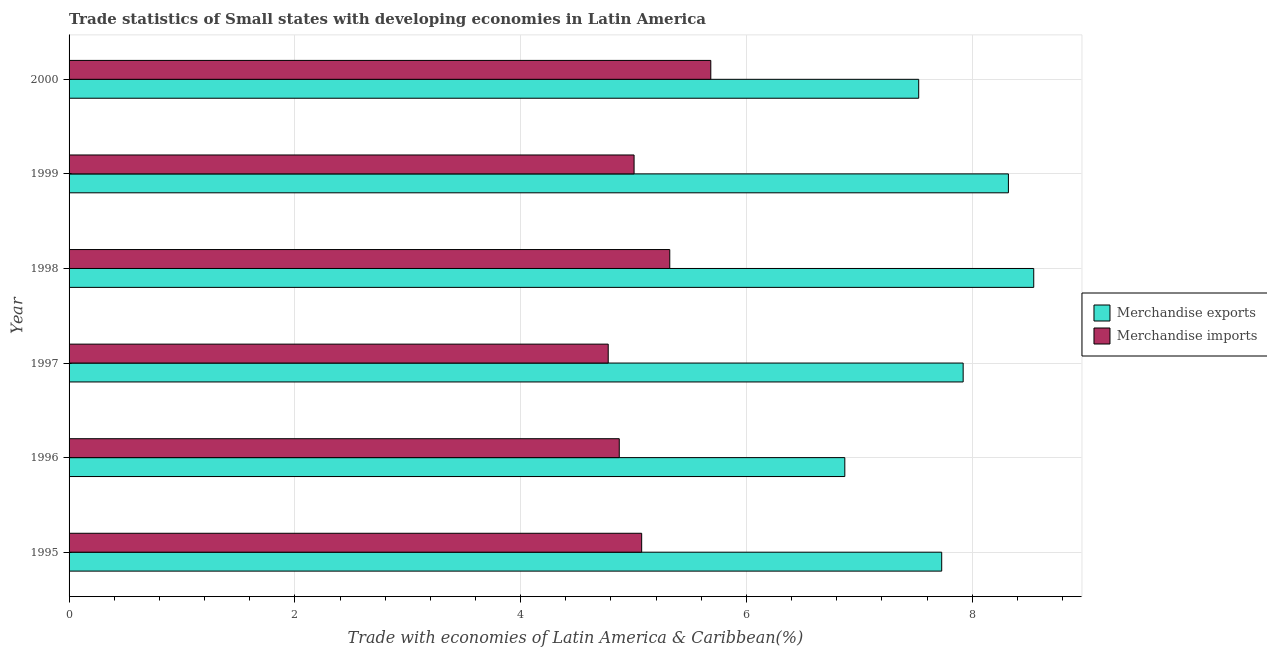How many groups of bars are there?
Give a very brief answer. 6. Are the number of bars on each tick of the Y-axis equal?
Provide a succinct answer. Yes. How many bars are there on the 5th tick from the bottom?
Offer a very short reply. 2. What is the label of the 6th group of bars from the top?
Your answer should be compact. 1995. What is the merchandise exports in 1997?
Keep it short and to the point. 7.92. Across all years, what is the maximum merchandise exports?
Provide a short and direct response. 8.54. Across all years, what is the minimum merchandise imports?
Give a very brief answer. 4.78. In which year was the merchandise imports minimum?
Your answer should be very brief. 1997. What is the total merchandise exports in the graph?
Offer a terse response. 46.91. What is the difference between the merchandise imports in 1995 and that in 2000?
Your answer should be very brief. -0.61. What is the difference between the merchandise imports in 1998 and the merchandise exports in 2000?
Keep it short and to the point. -2.21. What is the average merchandise exports per year?
Keep it short and to the point. 7.82. In the year 1995, what is the difference between the merchandise imports and merchandise exports?
Your response must be concise. -2.66. In how many years, is the merchandise exports greater than 4.4 %?
Provide a short and direct response. 6. What is the ratio of the merchandise imports in 1998 to that in 1999?
Offer a terse response. 1.06. What is the difference between the highest and the second highest merchandise exports?
Offer a very short reply. 0.22. What is the difference between the highest and the lowest merchandise exports?
Make the answer very short. 1.67. Is the sum of the merchandise imports in 1998 and 1999 greater than the maximum merchandise exports across all years?
Offer a terse response. Yes. What does the 1st bar from the top in 1997 represents?
Keep it short and to the point. Merchandise imports. Are all the bars in the graph horizontal?
Your response must be concise. Yes. How many years are there in the graph?
Ensure brevity in your answer.  6. Does the graph contain grids?
Give a very brief answer. Yes. Where does the legend appear in the graph?
Ensure brevity in your answer.  Center right. What is the title of the graph?
Keep it short and to the point. Trade statistics of Small states with developing economies in Latin America. Does "Nitrous oxide emissions" appear as one of the legend labels in the graph?
Make the answer very short. No. What is the label or title of the X-axis?
Keep it short and to the point. Trade with economies of Latin America & Caribbean(%). What is the Trade with economies of Latin America & Caribbean(%) of Merchandise exports in 1995?
Provide a short and direct response. 7.73. What is the Trade with economies of Latin America & Caribbean(%) of Merchandise imports in 1995?
Make the answer very short. 5.07. What is the Trade with economies of Latin America & Caribbean(%) of Merchandise exports in 1996?
Offer a terse response. 6.87. What is the Trade with economies of Latin America & Caribbean(%) in Merchandise imports in 1996?
Provide a succinct answer. 4.87. What is the Trade with economies of Latin America & Caribbean(%) in Merchandise exports in 1997?
Make the answer very short. 7.92. What is the Trade with economies of Latin America & Caribbean(%) of Merchandise imports in 1997?
Your answer should be very brief. 4.78. What is the Trade with economies of Latin America & Caribbean(%) of Merchandise exports in 1998?
Provide a succinct answer. 8.54. What is the Trade with economies of Latin America & Caribbean(%) in Merchandise imports in 1998?
Ensure brevity in your answer.  5.32. What is the Trade with economies of Latin America & Caribbean(%) in Merchandise exports in 1999?
Your answer should be very brief. 8.32. What is the Trade with economies of Latin America & Caribbean(%) of Merchandise imports in 1999?
Provide a short and direct response. 5. What is the Trade with economies of Latin America & Caribbean(%) in Merchandise exports in 2000?
Ensure brevity in your answer.  7.53. What is the Trade with economies of Latin America & Caribbean(%) of Merchandise imports in 2000?
Your response must be concise. 5.68. Across all years, what is the maximum Trade with economies of Latin America & Caribbean(%) in Merchandise exports?
Your answer should be very brief. 8.54. Across all years, what is the maximum Trade with economies of Latin America & Caribbean(%) of Merchandise imports?
Make the answer very short. 5.68. Across all years, what is the minimum Trade with economies of Latin America & Caribbean(%) in Merchandise exports?
Offer a very short reply. 6.87. Across all years, what is the minimum Trade with economies of Latin America & Caribbean(%) of Merchandise imports?
Make the answer very short. 4.78. What is the total Trade with economies of Latin America & Caribbean(%) in Merchandise exports in the graph?
Offer a terse response. 46.91. What is the total Trade with economies of Latin America & Caribbean(%) in Merchandise imports in the graph?
Offer a very short reply. 30.73. What is the difference between the Trade with economies of Latin America & Caribbean(%) in Merchandise exports in 1995 and that in 1996?
Offer a very short reply. 0.86. What is the difference between the Trade with economies of Latin America & Caribbean(%) of Merchandise imports in 1995 and that in 1996?
Make the answer very short. 0.2. What is the difference between the Trade with economies of Latin America & Caribbean(%) in Merchandise exports in 1995 and that in 1997?
Offer a very short reply. -0.19. What is the difference between the Trade with economies of Latin America & Caribbean(%) in Merchandise imports in 1995 and that in 1997?
Make the answer very short. 0.3. What is the difference between the Trade with economies of Latin America & Caribbean(%) of Merchandise exports in 1995 and that in 1998?
Offer a terse response. -0.82. What is the difference between the Trade with economies of Latin America & Caribbean(%) in Merchandise imports in 1995 and that in 1998?
Offer a terse response. -0.25. What is the difference between the Trade with economies of Latin America & Caribbean(%) of Merchandise exports in 1995 and that in 1999?
Your response must be concise. -0.59. What is the difference between the Trade with economies of Latin America & Caribbean(%) of Merchandise imports in 1995 and that in 1999?
Ensure brevity in your answer.  0.07. What is the difference between the Trade with economies of Latin America & Caribbean(%) in Merchandise exports in 1995 and that in 2000?
Keep it short and to the point. 0.2. What is the difference between the Trade with economies of Latin America & Caribbean(%) of Merchandise imports in 1995 and that in 2000?
Ensure brevity in your answer.  -0.61. What is the difference between the Trade with economies of Latin America & Caribbean(%) in Merchandise exports in 1996 and that in 1997?
Offer a very short reply. -1.05. What is the difference between the Trade with economies of Latin America & Caribbean(%) of Merchandise imports in 1996 and that in 1997?
Make the answer very short. 0.1. What is the difference between the Trade with economies of Latin America & Caribbean(%) of Merchandise exports in 1996 and that in 1998?
Your answer should be very brief. -1.67. What is the difference between the Trade with economies of Latin America & Caribbean(%) in Merchandise imports in 1996 and that in 1998?
Ensure brevity in your answer.  -0.45. What is the difference between the Trade with economies of Latin America & Caribbean(%) of Merchandise exports in 1996 and that in 1999?
Keep it short and to the point. -1.45. What is the difference between the Trade with economies of Latin America & Caribbean(%) in Merchandise imports in 1996 and that in 1999?
Offer a terse response. -0.13. What is the difference between the Trade with economies of Latin America & Caribbean(%) in Merchandise exports in 1996 and that in 2000?
Keep it short and to the point. -0.65. What is the difference between the Trade with economies of Latin America & Caribbean(%) in Merchandise imports in 1996 and that in 2000?
Offer a terse response. -0.81. What is the difference between the Trade with economies of Latin America & Caribbean(%) of Merchandise exports in 1997 and that in 1998?
Offer a terse response. -0.63. What is the difference between the Trade with economies of Latin America & Caribbean(%) in Merchandise imports in 1997 and that in 1998?
Your answer should be very brief. -0.55. What is the difference between the Trade with economies of Latin America & Caribbean(%) in Merchandise exports in 1997 and that in 1999?
Your answer should be very brief. -0.4. What is the difference between the Trade with economies of Latin America & Caribbean(%) of Merchandise imports in 1997 and that in 1999?
Provide a short and direct response. -0.23. What is the difference between the Trade with economies of Latin America & Caribbean(%) in Merchandise exports in 1997 and that in 2000?
Make the answer very short. 0.39. What is the difference between the Trade with economies of Latin America & Caribbean(%) in Merchandise imports in 1997 and that in 2000?
Offer a very short reply. -0.91. What is the difference between the Trade with economies of Latin America & Caribbean(%) of Merchandise exports in 1998 and that in 1999?
Your answer should be very brief. 0.22. What is the difference between the Trade with economies of Latin America & Caribbean(%) in Merchandise imports in 1998 and that in 1999?
Your response must be concise. 0.32. What is the difference between the Trade with economies of Latin America & Caribbean(%) of Merchandise exports in 1998 and that in 2000?
Your response must be concise. 1.02. What is the difference between the Trade with economies of Latin America & Caribbean(%) of Merchandise imports in 1998 and that in 2000?
Provide a short and direct response. -0.36. What is the difference between the Trade with economies of Latin America & Caribbean(%) of Merchandise exports in 1999 and that in 2000?
Your answer should be very brief. 0.79. What is the difference between the Trade with economies of Latin America & Caribbean(%) of Merchandise imports in 1999 and that in 2000?
Make the answer very short. -0.68. What is the difference between the Trade with economies of Latin America & Caribbean(%) of Merchandise exports in 1995 and the Trade with economies of Latin America & Caribbean(%) of Merchandise imports in 1996?
Give a very brief answer. 2.86. What is the difference between the Trade with economies of Latin America & Caribbean(%) in Merchandise exports in 1995 and the Trade with economies of Latin America & Caribbean(%) in Merchandise imports in 1997?
Provide a short and direct response. 2.95. What is the difference between the Trade with economies of Latin America & Caribbean(%) of Merchandise exports in 1995 and the Trade with economies of Latin America & Caribbean(%) of Merchandise imports in 1998?
Your response must be concise. 2.41. What is the difference between the Trade with economies of Latin America & Caribbean(%) of Merchandise exports in 1995 and the Trade with economies of Latin America & Caribbean(%) of Merchandise imports in 1999?
Offer a terse response. 2.72. What is the difference between the Trade with economies of Latin America & Caribbean(%) in Merchandise exports in 1995 and the Trade with economies of Latin America & Caribbean(%) in Merchandise imports in 2000?
Your answer should be compact. 2.05. What is the difference between the Trade with economies of Latin America & Caribbean(%) in Merchandise exports in 1996 and the Trade with economies of Latin America & Caribbean(%) in Merchandise imports in 1997?
Keep it short and to the point. 2.1. What is the difference between the Trade with economies of Latin America & Caribbean(%) of Merchandise exports in 1996 and the Trade with economies of Latin America & Caribbean(%) of Merchandise imports in 1998?
Provide a succinct answer. 1.55. What is the difference between the Trade with economies of Latin America & Caribbean(%) in Merchandise exports in 1996 and the Trade with economies of Latin America & Caribbean(%) in Merchandise imports in 1999?
Keep it short and to the point. 1.87. What is the difference between the Trade with economies of Latin America & Caribbean(%) of Merchandise exports in 1996 and the Trade with economies of Latin America & Caribbean(%) of Merchandise imports in 2000?
Your answer should be compact. 1.19. What is the difference between the Trade with economies of Latin America & Caribbean(%) in Merchandise exports in 1997 and the Trade with economies of Latin America & Caribbean(%) in Merchandise imports in 1998?
Offer a terse response. 2.6. What is the difference between the Trade with economies of Latin America & Caribbean(%) of Merchandise exports in 1997 and the Trade with economies of Latin America & Caribbean(%) of Merchandise imports in 1999?
Your answer should be very brief. 2.91. What is the difference between the Trade with economies of Latin America & Caribbean(%) in Merchandise exports in 1997 and the Trade with economies of Latin America & Caribbean(%) in Merchandise imports in 2000?
Provide a succinct answer. 2.24. What is the difference between the Trade with economies of Latin America & Caribbean(%) in Merchandise exports in 1998 and the Trade with economies of Latin America & Caribbean(%) in Merchandise imports in 1999?
Provide a short and direct response. 3.54. What is the difference between the Trade with economies of Latin America & Caribbean(%) in Merchandise exports in 1998 and the Trade with economies of Latin America & Caribbean(%) in Merchandise imports in 2000?
Give a very brief answer. 2.86. What is the difference between the Trade with economies of Latin America & Caribbean(%) in Merchandise exports in 1999 and the Trade with economies of Latin America & Caribbean(%) in Merchandise imports in 2000?
Offer a terse response. 2.64. What is the average Trade with economies of Latin America & Caribbean(%) of Merchandise exports per year?
Your answer should be very brief. 7.82. What is the average Trade with economies of Latin America & Caribbean(%) in Merchandise imports per year?
Offer a terse response. 5.12. In the year 1995, what is the difference between the Trade with economies of Latin America & Caribbean(%) of Merchandise exports and Trade with economies of Latin America & Caribbean(%) of Merchandise imports?
Provide a short and direct response. 2.66. In the year 1996, what is the difference between the Trade with economies of Latin America & Caribbean(%) in Merchandise exports and Trade with economies of Latin America & Caribbean(%) in Merchandise imports?
Provide a short and direct response. 2. In the year 1997, what is the difference between the Trade with economies of Latin America & Caribbean(%) of Merchandise exports and Trade with economies of Latin America & Caribbean(%) of Merchandise imports?
Make the answer very short. 3.14. In the year 1998, what is the difference between the Trade with economies of Latin America & Caribbean(%) in Merchandise exports and Trade with economies of Latin America & Caribbean(%) in Merchandise imports?
Ensure brevity in your answer.  3.22. In the year 1999, what is the difference between the Trade with economies of Latin America & Caribbean(%) of Merchandise exports and Trade with economies of Latin America & Caribbean(%) of Merchandise imports?
Ensure brevity in your answer.  3.32. In the year 2000, what is the difference between the Trade with economies of Latin America & Caribbean(%) of Merchandise exports and Trade with economies of Latin America & Caribbean(%) of Merchandise imports?
Give a very brief answer. 1.84. What is the ratio of the Trade with economies of Latin America & Caribbean(%) in Merchandise exports in 1995 to that in 1996?
Provide a succinct answer. 1.12. What is the ratio of the Trade with economies of Latin America & Caribbean(%) in Merchandise imports in 1995 to that in 1996?
Ensure brevity in your answer.  1.04. What is the ratio of the Trade with economies of Latin America & Caribbean(%) in Merchandise exports in 1995 to that in 1997?
Your response must be concise. 0.98. What is the ratio of the Trade with economies of Latin America & Caribbean(%) in Merchandise imports in 1995 to that in 1997?
Make the answer very short. 1.06. What is the ratio of the Trade with economies of Latin America & Caribbean(%) in Merchandise exports in 1995 to that in 1998?
Ensure brevity in your answer.  0.9. What is the ratio of the Trade with economies of Latin America & Caribbean(%) of Merchandise imports in 1995 to that in 1998?
Offer a terse response. 0.95. What is the ratio of the Trade with economies of Latin America & Caribbean(%) of Merchandise exports in 1995 to that in 1999?
Make the answer very short. 0.93. What is the ratio of the Trade with economies of Latin America & Caribbean(%) of Merchandise imports in 1995 to that in 1999?
Ensure brevity in your answer.  1.01. What is the ratio of the Trade with economies of Latin America & Caribbean(%) of Merchandise exports in 1995 to that in 2000?
Provide a short and direct response. 1.03. What is the ratio of the Trade with economies of Latin America & Caribbean(%) in Merchandise imports in 1995 to that in 2000?
Offer a very short reply. 0.89. What is the ratio of the Trade with economies of Latin America & Caribbean(%) in Merchandise exports in 1996 to that in 1997?
Your answer should be very brief. 0.87. What is the ratio of the Trade with economies of Latin America & Caribbean(%) in Merchandise imports in 1996 to that in 1997?
Your answer should be very brief. 1.02. What is the ratio of the Trade with economies of Latin America & Caribbean(%) of Merchandise exports in 1996 to that in 1998?
Make the answer very short. 0.8. What is the ratio of the Trade with economies of Latin America & Caribbean(%) of Merchandise imports in 1996 to that in 1998?
Offer a terse response. 0.92. What is the ratio of the Trade with economies of Latin America & Caribbean(%) of Merchandise exports in 1996 to that in 1999?
Offer a terse response. 0.83. What is the ratio of the Trade with economies of Latin America & Caribbean(%) in Merchandise imports in 1996 to that in 1999?
Keep it short and to the point. 0.97. What is the ratio of the Trade with economies of Latin America & Caribbean(%) in Merchandise imports in 1996 to that in 2000?
Ensure brevity in your answer.  0.86. What is the ratio of the Trade with economies of Latin America & Caribbean(%) of Merchandise exports in 1997 to that in 1998?
Make the answer very short. 0.93. What is the ratio of the Trade with economies of Latin America & Caribbean(%) in Merchandise imports in 1997 to that in 1998?
Ensure brevity in your answer.  0.9. What is the ratio of the Trade with economies of Latin America & Caribbean(%) in Merchandise exports in 1997 to that in 1999?
Your response must be concise. 0.95. What is the ratio of the Trade with economies of Latin America & Caribbean(%) of Merchandise imports in 1997 to that in 1999?
Offer a terse response. 0.95. What is the ratio of the Trade with economies of Latin America & Caribbean(%) in Merchandise exports in 1997 to that in 2000?
Your answer should be compact. 1.05. What is the ratio of the Trade with economies of Latin America & Caribbean(%) of Merchandise imports in 1997 to that in 2000?
Provide a succinct answer. 0.84. What is the ratio of the Trade with economies of Latin America & Caribbean(%) of Merchandise exports in 1998 to that in 1999?
Ensure brevity in your answer.  1.03. What is the ratio of the Trade with economies of Latin America & Caribbean(%) of Merchandise imports in 1998 to that in 1999?
Offer a very short reply. 1.06. What is the ratio of the Trade with economies of Latin America & Caribbean(%) in Merchandise exports in 1998 to that in 2000?
Make the answer very short. 1.14. What is the ratio of the Trade with economies of Latin America & Caribbean(%) in Merchandise imports in 1998 to that in 2000?
Your response must be concise. 0.94. What is the ratio of the Trade with economies of Latin America & Caribbean(%) of Merchandise exports in 1999 to that in 2000?
Keep it short and to the point. 1.11. What is the ratio of the Trade with economies of Latin America & Caribbean(%) in Merchandise imports in 1999 to that in 2000?
Your response must be concise. 0.88. What is the difference between the highest and the second highest Trade with economies of Latin America & Caribbean(%) in Merchandise exports?
Keep it short and to the point. 0.22. What is the difference between the highest and the second highest Trade with economies of Latin America & Caribbean(%) of Merchandise imports?
Offer a terse response. 0.36. What is the difference between the highest and the lowest Trade with economies of Latin America & Caribbean(%) of Merchandise exports?
Offer a terse response. 1.67. What is the difference between the highest and the lowest Trade with economies of Latin America & Caribbean(%) in Merchandise imports?
Your response must be concise. 0.91. 